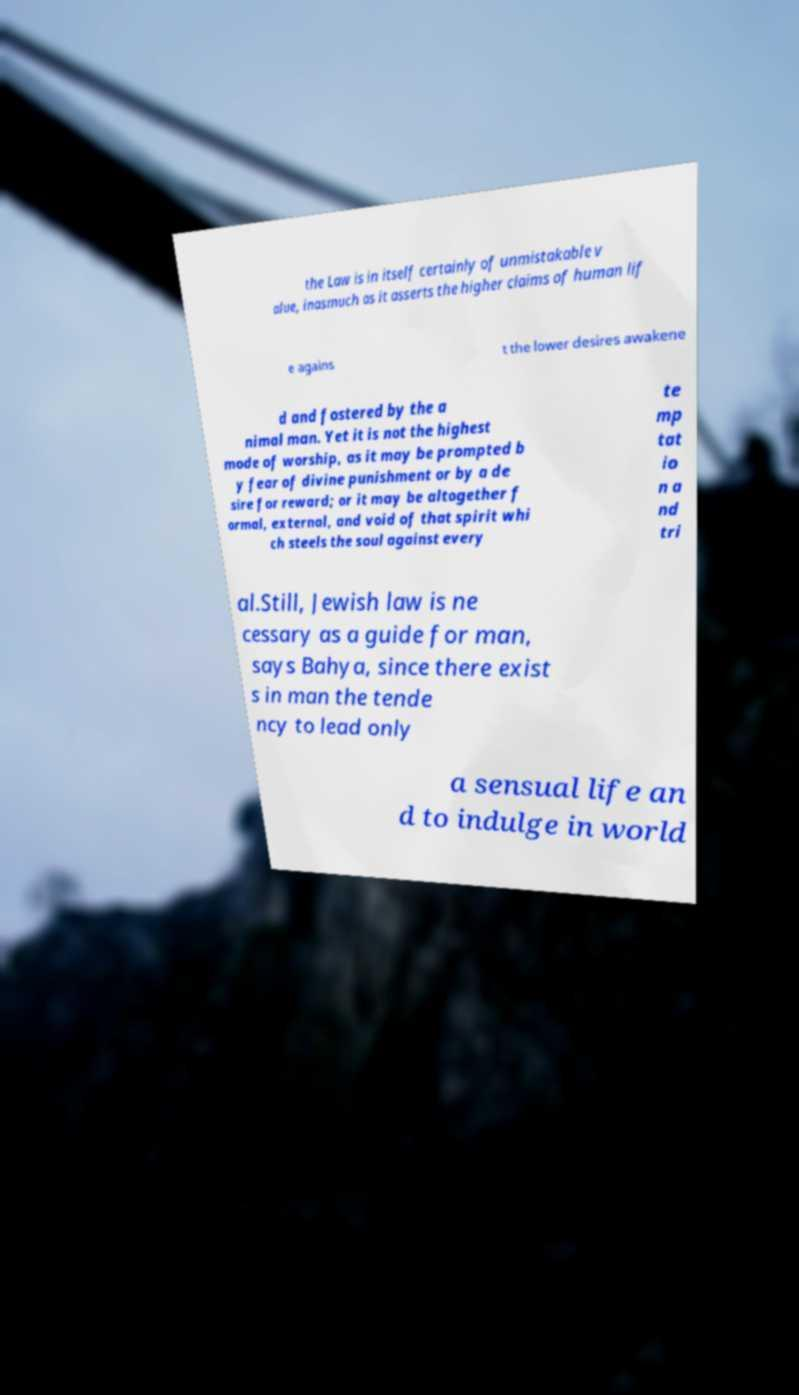What messages or text are displayed in this image? I need them in a readable, typed format. the Law is in itself certainly of unmistakable v alue, inasmuch as it asserts the higher claims of human lif e agains t the lower desires awakene d and fostered by the a nimal man. Yet it is not the highest mode of worship, as it may be prompted b y fear of divine punishment or by a de sire for reward; or it may be altogether f ormal, external, and void of that spirit whi ch steels the soul against every te mp tat io n a nd tri al.Still, Jewish law is ne cessary as a guide for man, says Bahya, since there exist s in man the tende ncy to lead only a sensual life an d to indulge in world 